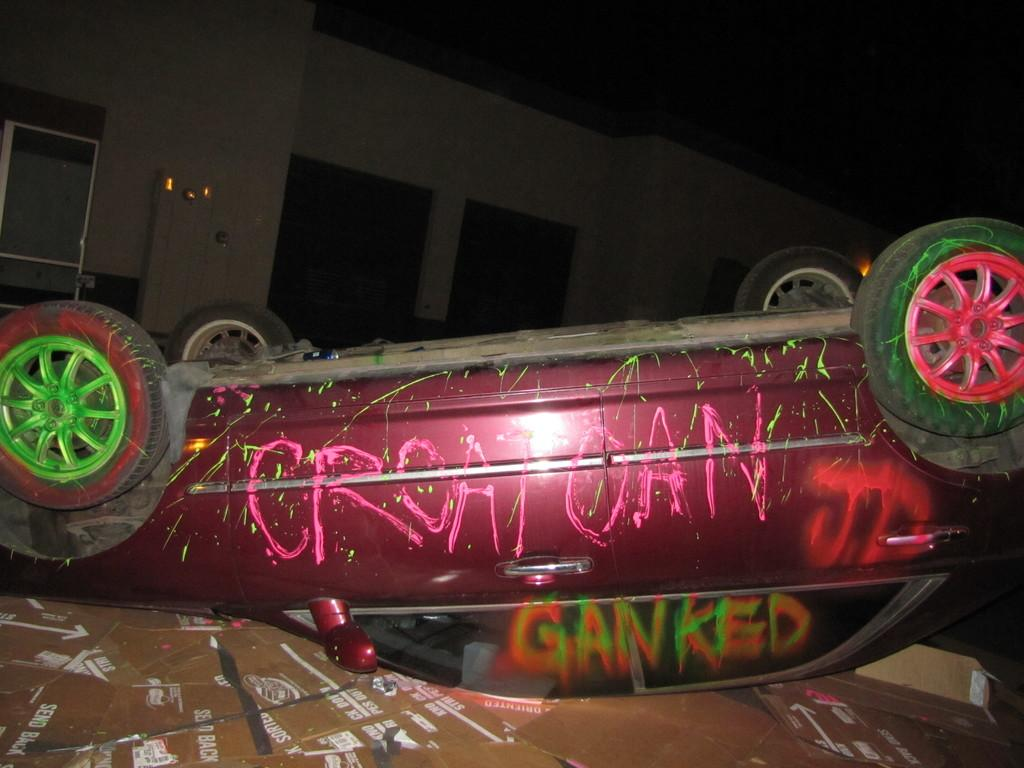What type of vehicle is in the image? There is a vehicle in the image, but the specific type is not mentioned. What material is present in the image? Cardboard is present in the image. What is a prominent feature in the background of the image? There is a wall in the image. Can you describe the objects in the image? There are objects in the image, but their specific nature is not mentioned. What is written on the vehicle? Something is written on the vehicle, but the content is not mentioned. What is written on the cardboard? Something is written on the cardboard, but the content is not mentioned. What type of orange is being used to crack the powder in the image? There is no orange, cracker, or powder present in the image. 